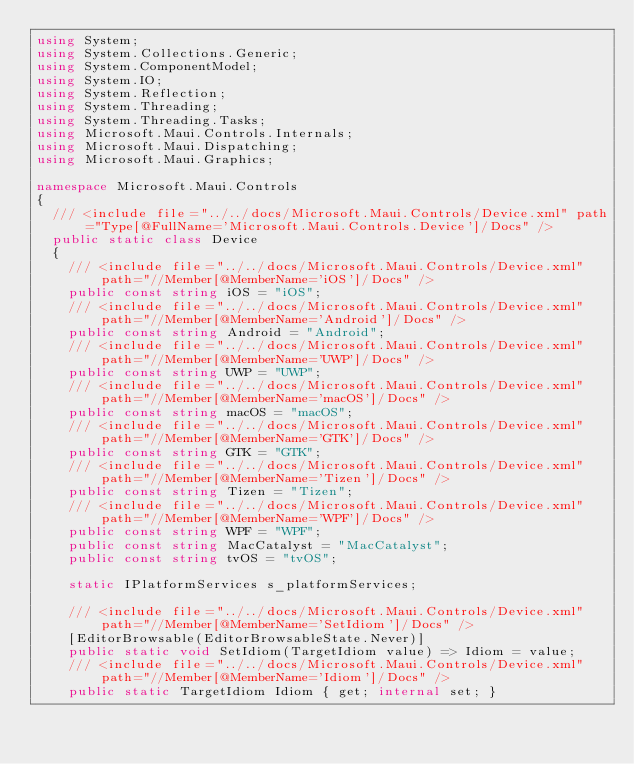<code> <loc_0><loc_0><loc_500><loc_500><_C#_>using System;
using System.Collections.Generic;
using System.ComponentModel;
using System.IO;
using System.Reflection;
using System.Threading;
using System.Threading.Tasks;
using Microsoft.Maui.Controls.Internals;
using Microsoft.Maui.Dispatching;
using Microsoft.Maui.Graphics;

namespace Microsoft.Maui.Controls
{
	/// <include file="../../docs/Microsoft.Maui.Controls/Device.xml" path="Type[@FullName='Microsoft.Maui.Controls.Device']/Docs" />
	public static class Device
	{
		/// <include file="../../docs/Microsoft.Maui.Controls/Device.xml" path="//Member[@MemberName='iOS']/Docs" />
		public const string iOS = "iOS";
		/// <include file="../../docs/Microsoft.Maui.Controls/Device.xml" path="//Member[@MemberName='Android']/Docs" />
		public const string Android = "Android";
		/// <include file="../../docs/Microsoft.Maui.Controls/Device.xml" path="//Member[@MemberName='UWP']/Docs" />
		public const string UWP = "UWP";
		/// <include file="../../docs/Microsoft.Maui.Controls/Device.xml" path="//Member[@MemberName='macOS']/Docs" />
		public const string macOS = "macOS";
		/// <include file="../../docs/Microsoft.Maui.Controls/Device.xml" path="//Member[@MemberName='GTK']/Docs" />
		public const string GTK = "GTK";
		/// <include file="../../docs/Microsoft.Maui.Controls/Device.xml" path="//Member[@MemberName='Tizen']/Docs" />
		public const string Tizen = "Tizen";
		/// <include file="../../docs/Microsoft.Maui.Controls/Device.xml" path="//Member[@MemberName='WPF']/Docs" />
		public const string WPF = "WPF";
		public const string MacCatalyst = "MacCatalyst";
		public const string tvOS = "tvOS";

		static IPlatformServices s_platformServices;

		/// <include file="../../docs/Microsoft.Maui.Controls/Device.xml" path="//Member[@MemberName='SetIdiom']/Docs" />
		[EditorBrowsable(EditorBrowsableState.Never)]
		public static void SetIdiom(TargetIdiom value) => Idiom = value;
		/// <include file="../../docs/Microsoft.Maui.Controls/Device.xml" path="//Member[@MemberName='Idiom']/Docs" />
		public static TargetIdiom Idiom { get; internal set; }
</code> 